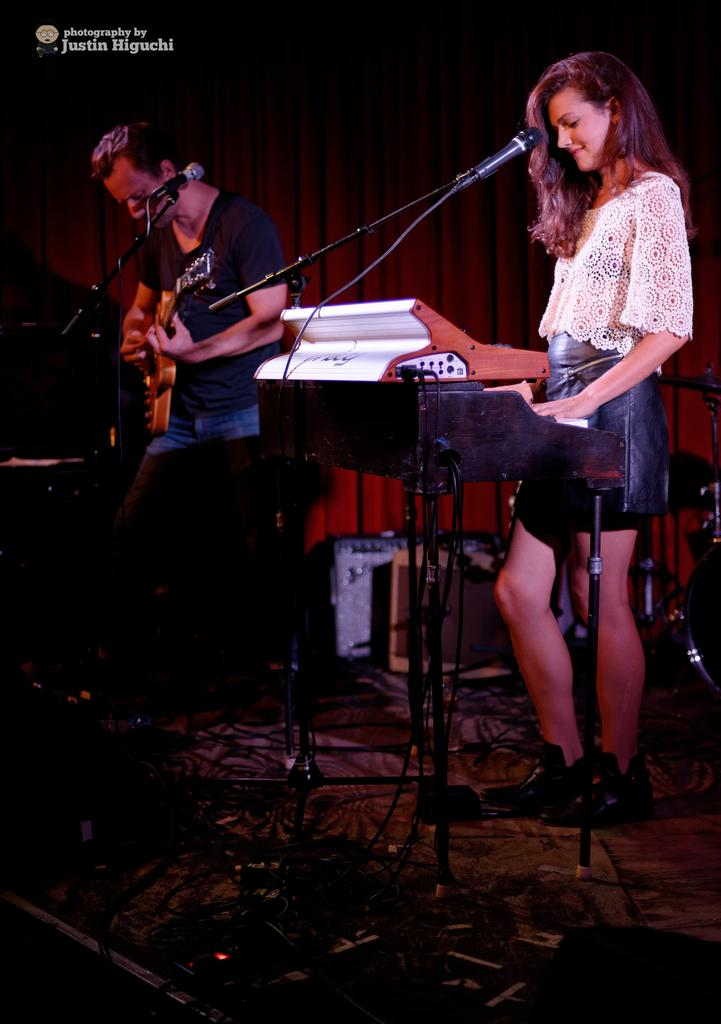What is the woman in the image doing? The woman is standing and playing a piano, and she is using a microphone. What is the man in the image doing? The man is standing and playing a guitar, and he is using a microphone. What are the woman and man using to amplify their voices? They are both using microphones. What type of air can be seen coming from the guitar in the image? There is no air coming from the guitar in the image; it is a musical instrument being played by the man. What advice is the woman giving to the man in the image? There is no indication in the image that the woman is giving advice to the man. 